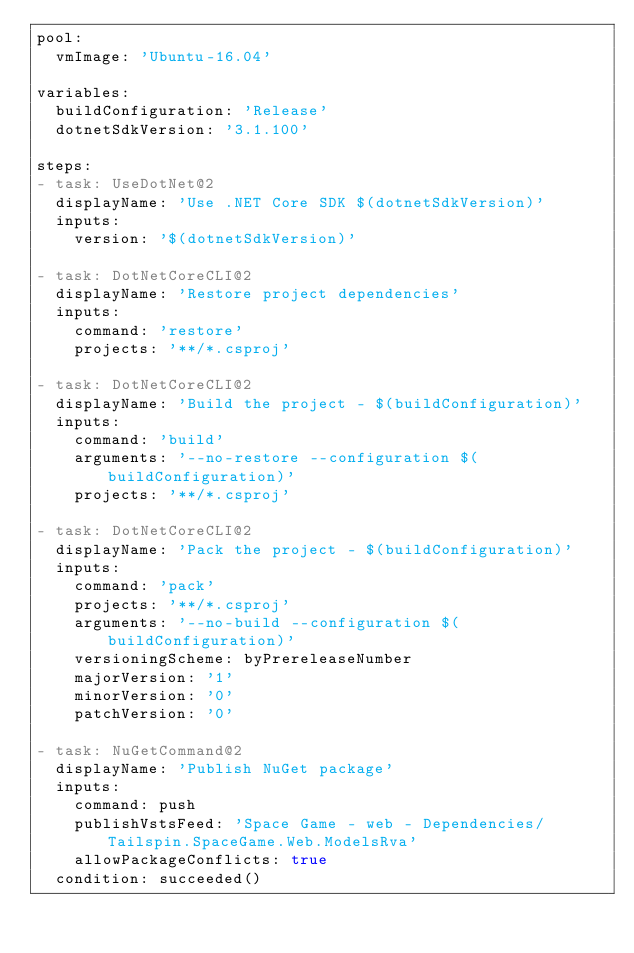<code> <loc_0><loc_0><loc_500><loc_500><_YAML_>pool:
  vmImage: 'Ubuntu-16.04'

variables:
  buildConfiguration: 'Release'
  dotnetSdkVersion: '3.1.100'

steps:
- task: UseDotNet@2
  displayName: 'Use .NET Core SDK $(dotnetSdkVersion)'
  inputs:
    version: '$(dotnetSdkVersion)'

- task: DotNetCoreCLI@2
  displayName: 'Restore project dependencies'
  inputs:
    command: 'restore'
    projects: '**/*.csproj'

- task: DotNetCoreCLI@2
  displayName: 'Build the project - $(buildConfiguration)'
  inputs:
    command: 'build'
    arguments: '--no-restore --configuration $(buildConfiguration)'
    projects: '**/*.csproj'

- task: DotNetCoreCLI@2
  displayName: 'Pack the project - $(buildConfiguration)'
  inputs:
    command: 'pack'
    projects: '**/*.csproj'
    arguments: '--no-build --configuration $(buildConfiguration)'
    versioningScheme: byPrereleaseNumber
    majorVersion: '1'
    minorVersion: '0'
    patchVersion: '0'
 
- task: NuGetCommand@2
  displayName: 'Publish NuGet package'
  inputs:
    command: push
    publishVstsFeed: 'Space Game - web - Dependencies/Tailspin.SpaceGame.Web.ModelsRva'
    allowPackageConflicts: true
  condition: succeeded()
</code> 